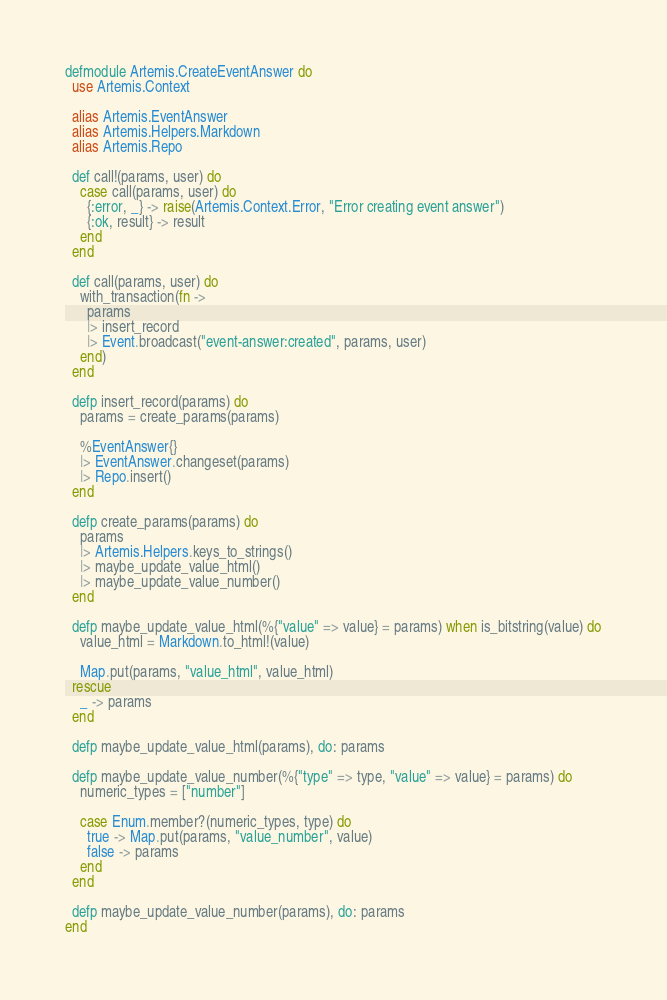<code> <loc_0><loc_0><loc_500><loc_500><_Elixir_>defmodule Artemis.CreateEventAnswer do
  use Artemis.Context

  alias Artemis.EventAnswer
  alias Artemis.Helpers.Markdown
  alias Artemis.Repo

  def call!(params, user) do
    case call(params, user) do
      {:error, _} -> raise(Artemis.Context.Error, "Error creating event answer")
      {:ok, result} -> result
    end
  end

  def call(params, user) do
    with_transaction(fn ->
      params
      |> insert_record
      |> Event.broadcast("event-answer:created", params, user)
    end)
  end

  defp insert_record(params) do
    params = create_params(params)

    %EventAnswer{}
    |> EventAnswer.changeset(params)
    |> Repo.insert()
  end

  defp create_params(params) do
    params
    |> Artemis.Helpers.keys_to_strings()
    |> maybe_update_value_html()
    |> maybe_update_value_number()
  end

  defp maybe_update_value_html(%{"value" => value} = params) when is_bitstring(value) do
    value_html = Markdown.to_html!(value)

    Map.put(params, "value_html", value_html)
  rescue
    _ -> params
  end

  defp maybe_update_value_html(params), do: params

  defp maybe_update_value_number(%{"type" => type, "value" => value} = params) do
    numeric_types = ["number"]

    case Enum.member?(numeric_types, type) do
      true -> Map.put(params, "value_number", value)
      false -> params
    end
  end

  defp maybe_update_value_number(params), do: params
end
</code> 